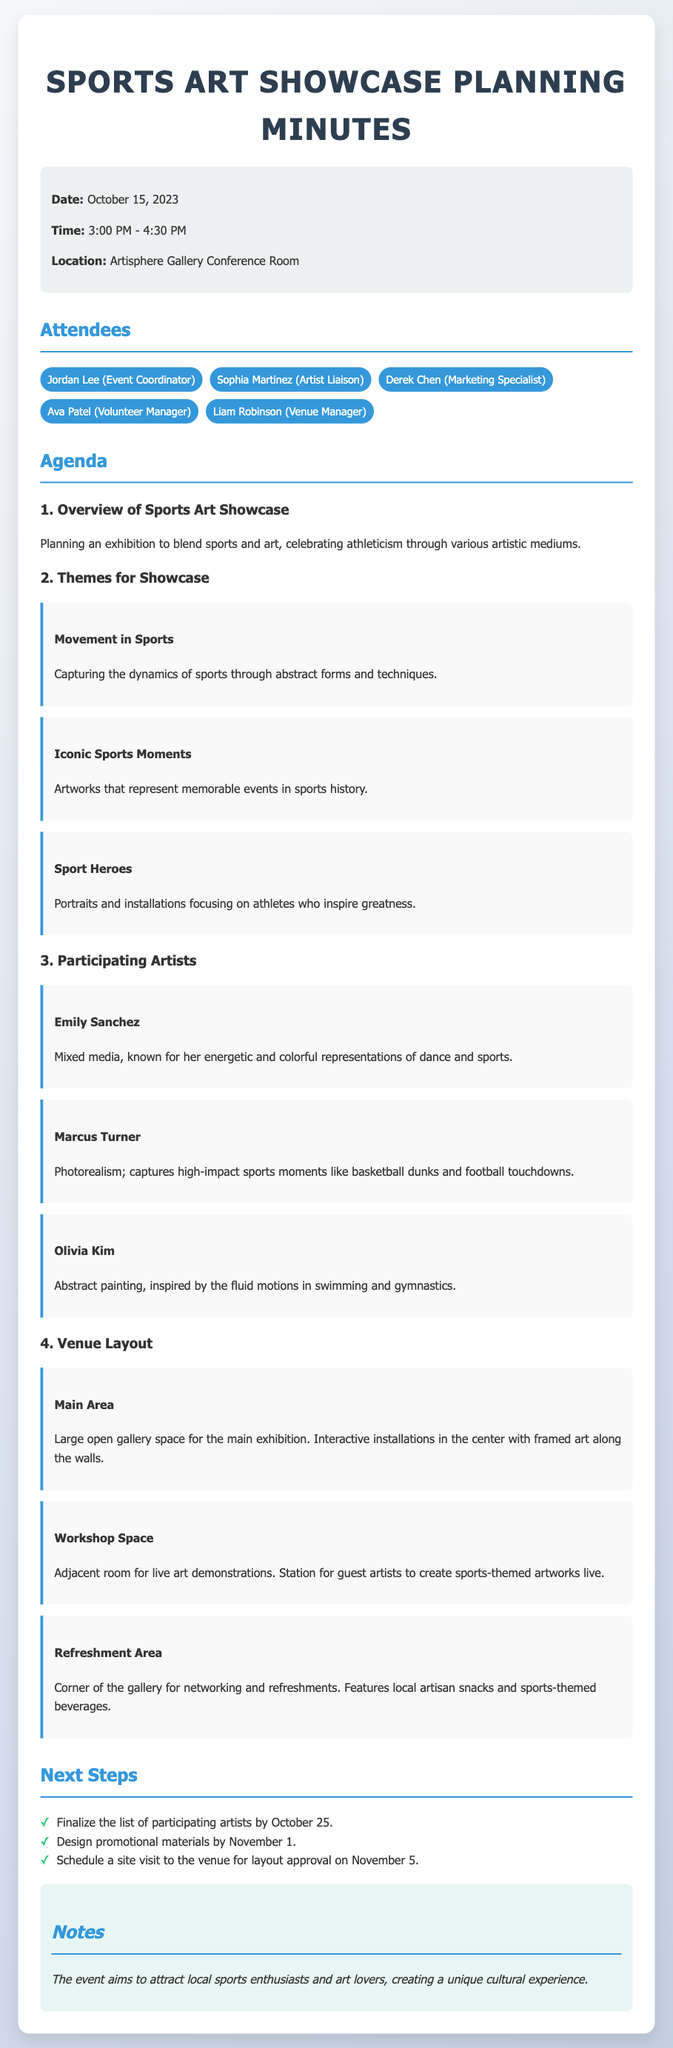What is the date of the meeting? The date of the meeting is explicitly stated in the document as October 15, 2023.
Answer: October 15, 2023 Who is the Artist Liaison? The document lists Sophia Martinez as the Artist Liaison under the attendees section.
Answer: Sophia Martinez What is one of the themes for the showcase? Several themes are listed in the document, one of which is "Movement in Sports."
Answer: Movement in Sports How many participating artists are mentioned? The document lists a total of three participating artists under the relevant section.
Answer: Three What is the purpose of the Refreshment Area? The document describes it as a space for networking and refreshments, located in the corner of the gallery.
Answer: Networking and refreshments What is the deadline for finalizing the list of participating artists? The document specifies that the deadline for finalizing the list is October 25.
Answer: October 25 Which space is designated for live art demonstrations? The document identifies the "Workshop Space" as the area for live art demonstrations adjacent to the main area.
Answer: Workshop Space What kind of artworks will Marcus Turner create? The document states that Marcus Turner focuses on photorealism, capturing high-impact sports moments.
Answer: Photorealism During what time was the meeting held? The time of the meeting is detailed in the document as taking place from 3:00 PM to 4:30 PM.
Answer: 3:00 PM - 4:30 PM 